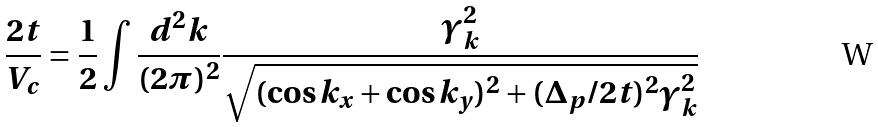Convert formula to latex. <formula><loc_0><loc_0><loc_500><loc_500>\frac { 2 t } { V _ { c } } = \frac { 1 } { 2 } \int \frac { d ^ { 2 } k } { ( 2 \pi ) ^ { 2 } } \frac { \gamma _ { k } ^ { 2 } } { \sqrt { ( \cos k _ { x } + \cos k _ { y } ) ^ { 2 } + ( \Delta _ { p } / 2 t ) ^ { 2 } \gamma _ { k } ^ { 2 } } }</formula> 